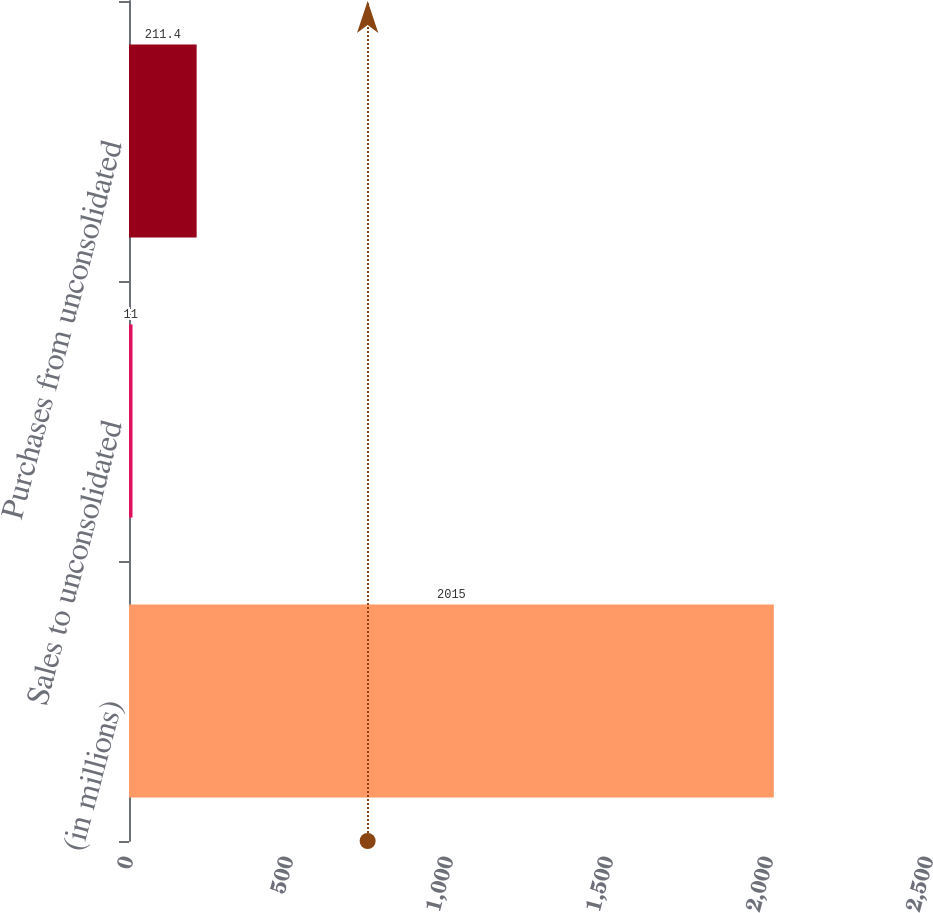Convert chart. <chart><loc_0><loc_0><loc_500><loc_500><bar_chart><fcel>(in millions)<fcel>Sales to unconsolidated<fcel>Purchases from unconsolidated<nl><fcel>2015<fcel>11<fcel>211.4<nl></chart> 